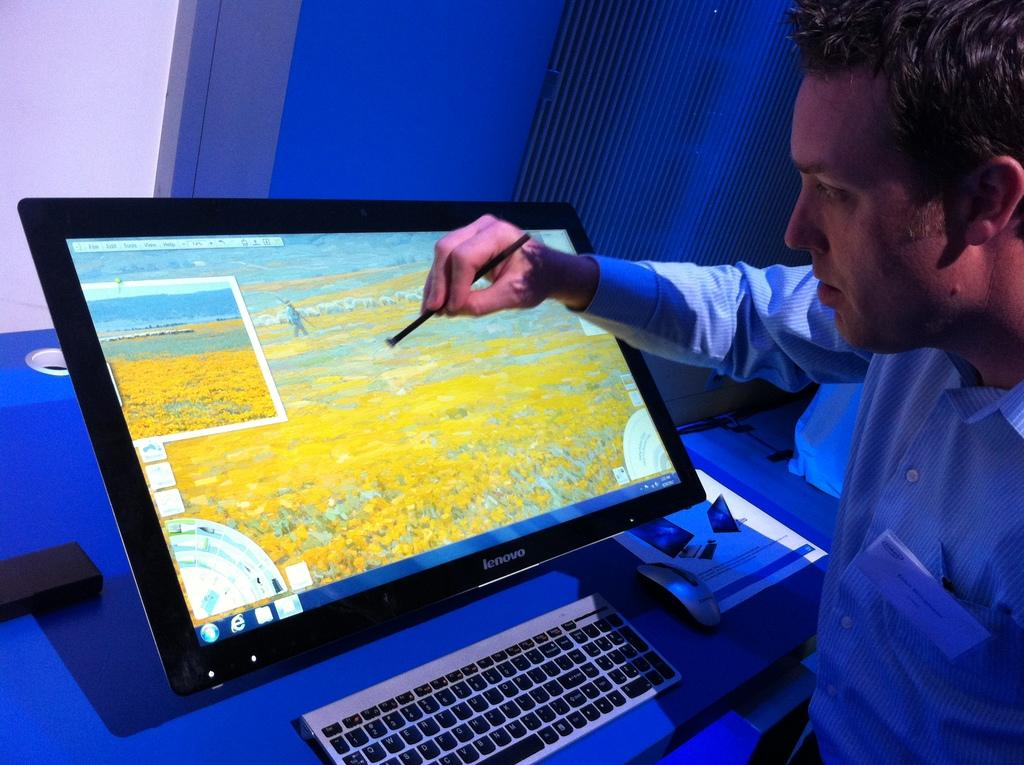Provide a one-sentence caption for the provided image. A man draws with a stylus on his Lenovo monitor. 